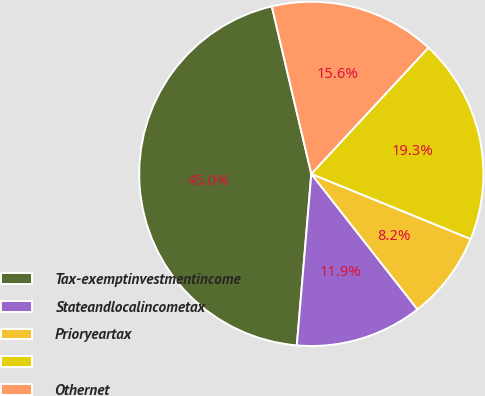<chart> <loc_0><loc_0><loc_500><loc_500><pie_chart><fcel>Tax-exemptinvestmentincome<fcel>Stateandlocalincometax<fcel>Prioryeartax<fcel>Unnamed: 3<fcel>Othernet<nl><fcel>44.97%<fcel>11.92%<fcel>8.25%<fcel>19.27%<fcel>15.59%<nl></chart> 